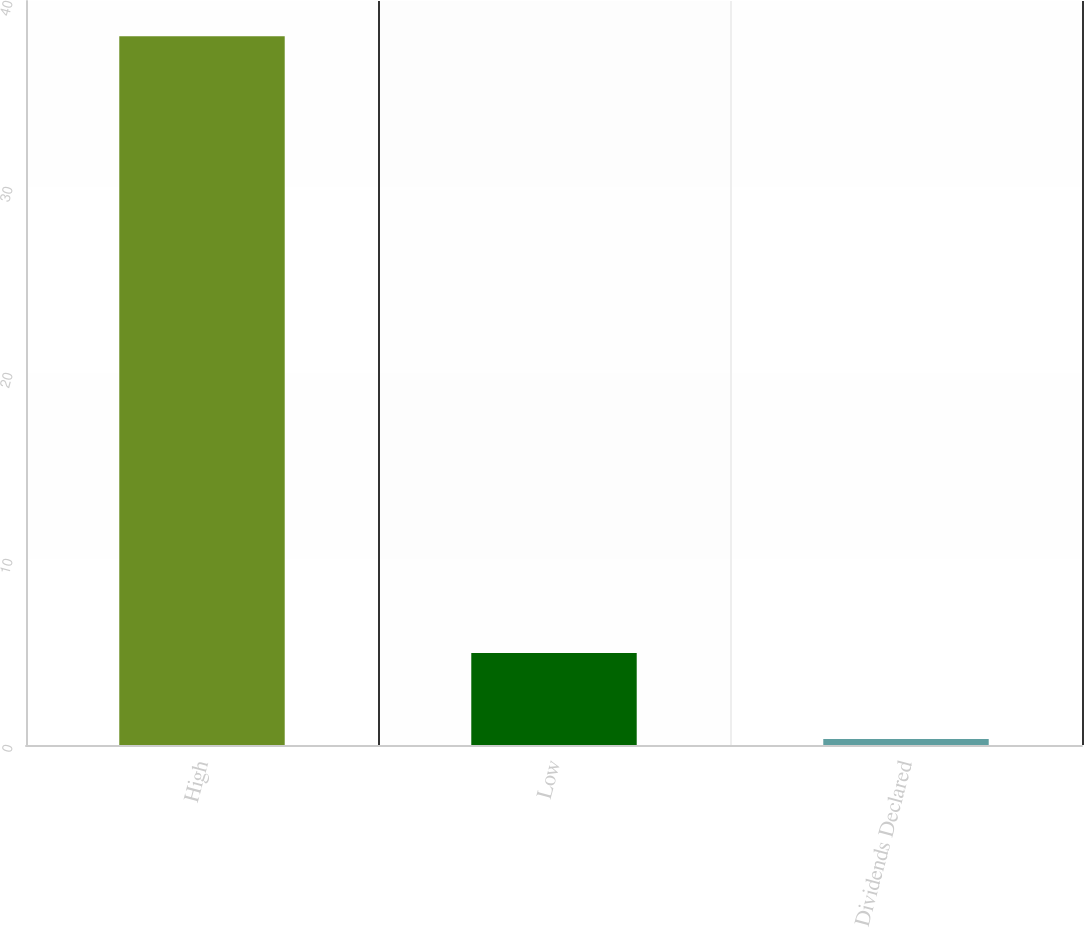Convert chart to OTSL. <chart><loc_0><loc_0><loc_500><loc_500><bar_chart><fcel>High<fcel>Low<fcel>Dividends Declared<nl><fcel>38.11<fcel>4.95<fcel>0.32<nl></chart> 